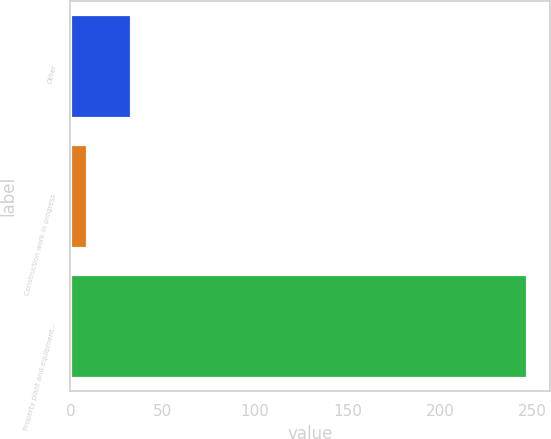Convert chart to OTSL. <chart><loc_0><loc_0><loc_500><loc_500><bar_chart><fcel>Other<fcel>Construction work in progress<fcel>Property plant and equipment -<nl><fcel>32.8<fcel>9<fcel>247<nl></chart> 